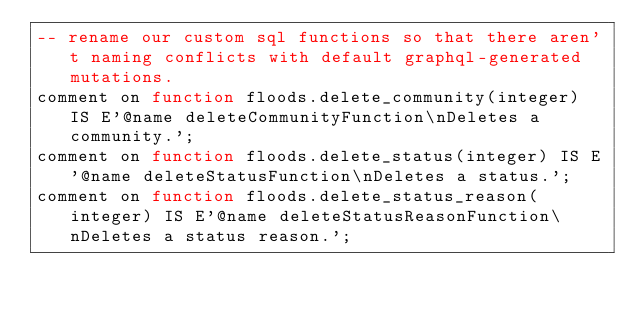<code> <loc_0><loc_0><loc_500><loc_500><_SQL_>-- rename our custom sql functions so that there aren't naming conflicts with default graphql-generated mutations.
comment on function floods.delete_community(integer) IS E'@name deleteCommunityFunction\nDeletes a community.';
comment on function floods.delete_status(integer) IS E'@name deleteStatusFunction\nDeletes a status.';
comment on function floods.delete_status_reason(integer) IS E'@name deleteStatusReasonFunction\nDeletes a status reason.';
</code> 